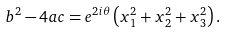Convert formula to latex. <formula><loc_0><loc_0><loc_500><loc_500>b ^ { 2 } - 4 a c = e ^ { 2 i \theta } \left ( x _ { 1 } ^ { 2 } + x _ { 2 } ^ { 2 } + x _ { 3 } ^ { 2 } \right ) .</formula> 